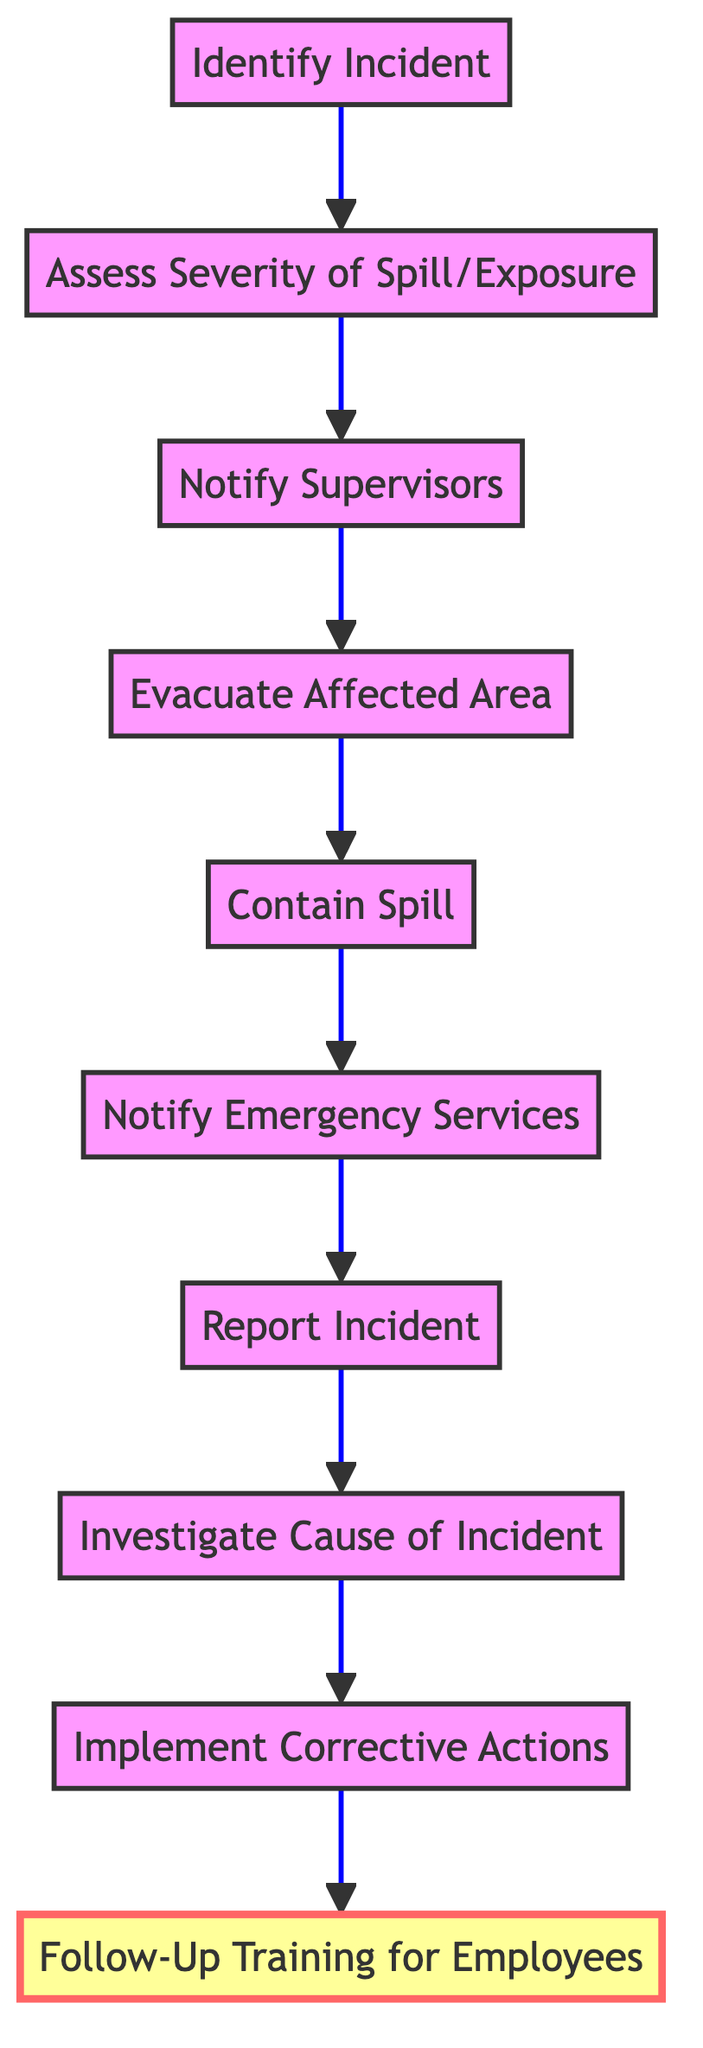What is the last step in the incident reporting process? The last step in the process, based on the flow from the starting node to the ending node in the diagram, is "Follow-Up Training for Employees." This is indicated as the final node in the directed graph.
Answer: Follow-Up Training for Employees How many nodes are present in the diagram? To determine the total number of nodes, one can count each unique node listed in the data provided. There are 10 nodes in the diagram, each representing a distinct step in the incident reporting process.
Answer: 10 Which node follows "Notify Supervisors"? In the directed flow of the diagram, the node that immediately follows "Notify Supervisors" is "Evacuate Affected Area." This is determined by tracing the edge leading from "Notify Supervisors" to the next node.
Answer: Evacuate Affected Area What action is taken after "Contain Spill"? The action that follows "Contain Spill" according to the diagram is to "Notify Emergency Services." This link is explicitly shown between the two nodes, indicating the sequence of actions.
Answer: Notify Emergency Services What is the relationship between "Investigate Cause" and "Implement Corrective Actions"? The relationship is that "Investigate Cause" leads to "Implement Corrective Actions," meaning that after investigating the cause of the incident, the next step is to implement the corrective actions. This is a direct edge from one node to the other in the graph.
Answer: Leads to 